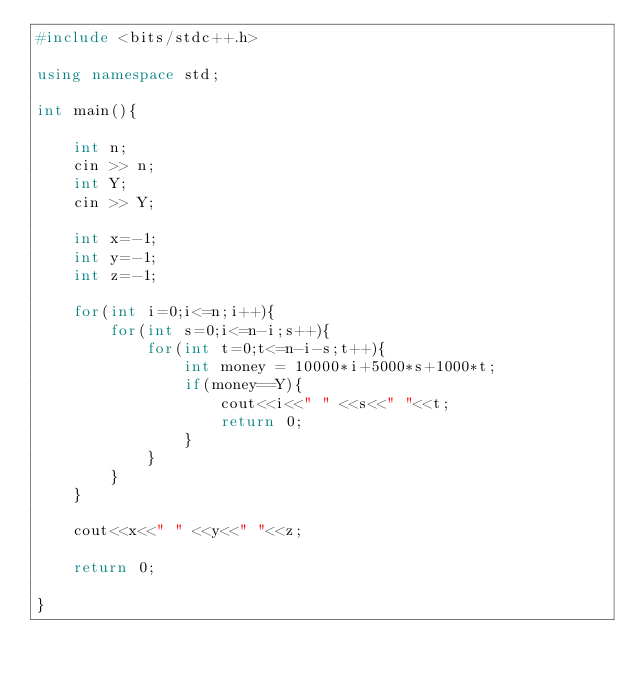Convert code to text. <code><loc_0><loc_0><loc_500><loc_500><_C++_>#include <bits/stdc++.h>

using namespace std;

int main(){

	int n;
	cin >> n;
	int Y;
	cin >> Y;

	int x=-1;
	int y=-1;
	int z=-1;

	for(int i=0;i<=n;i++){
		for(int s=0;i<=n-i;s++){
			for(int t=0;t<=n-i-s;t++){
				int money = 10000*i+5000*s+1000*t;
				if(money==Y){
					cout<<i<<" " <<s<<" "<<t;
					return 0;				
				}					
			}
		}
	}

	cout<<x<<" " <<y<<" "<<z;	

	return 0;

}</code> 